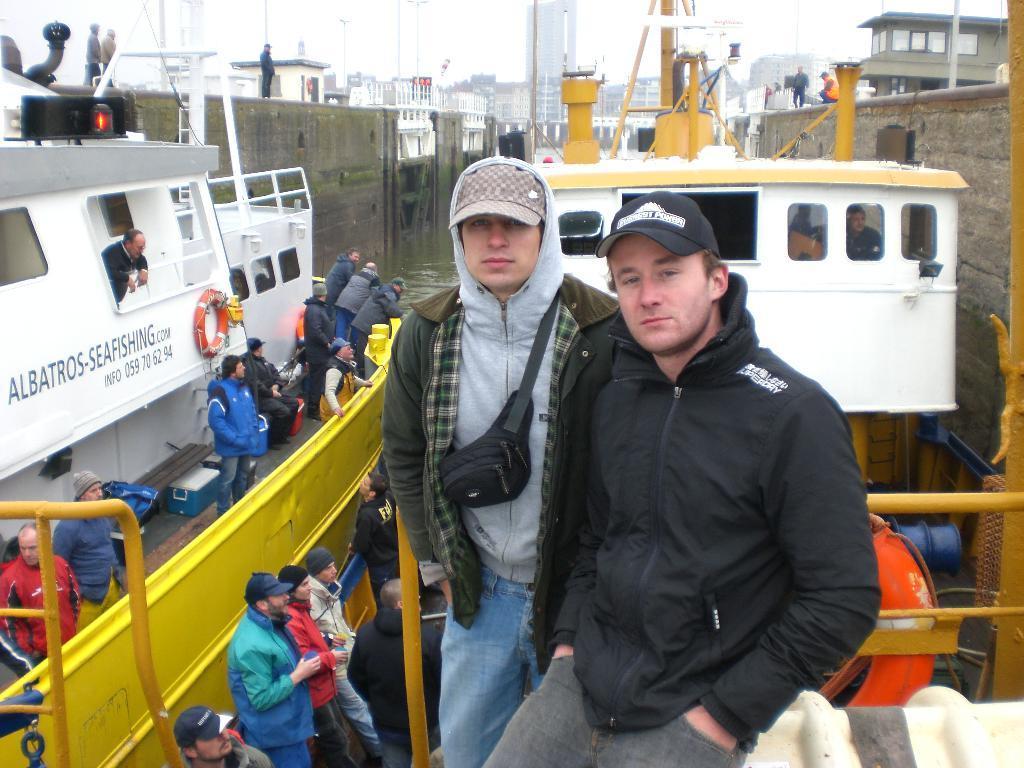Could you give a brief overview of what you see in this image? At the top of the image we can see the sky and the buildings. At the bottom of the image we can see two boats, people and inflatable object. On the both sides of the image, we can see the walls. 